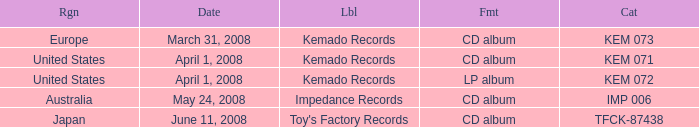Give me the full table as a dictionary. {'header': ['Rgn', 'Date', 'Lbl', 'Fmt', 'Cat'], 'rows': [['Europe', 'March 31, 2008', 'Kemado Records', 'CD album', 'KEM 073'], ['United States', 'April 1, 2008', 'Kemado Records', 'CD album', 'KEM 071'], ['United States', 'April 1, 2008', 'Kemado Records', 'LP album', 'KEM 072'], ['Australia', 'May 24, 2008', 'Impedance Records', 'CD album', 'IMP 006'], ['Japan', 'June 11, 2008', "Toy's Factory Records", 'CD album', 'TFCK-87438']]} Which Format has a Label of toy's factory records? CD album. 